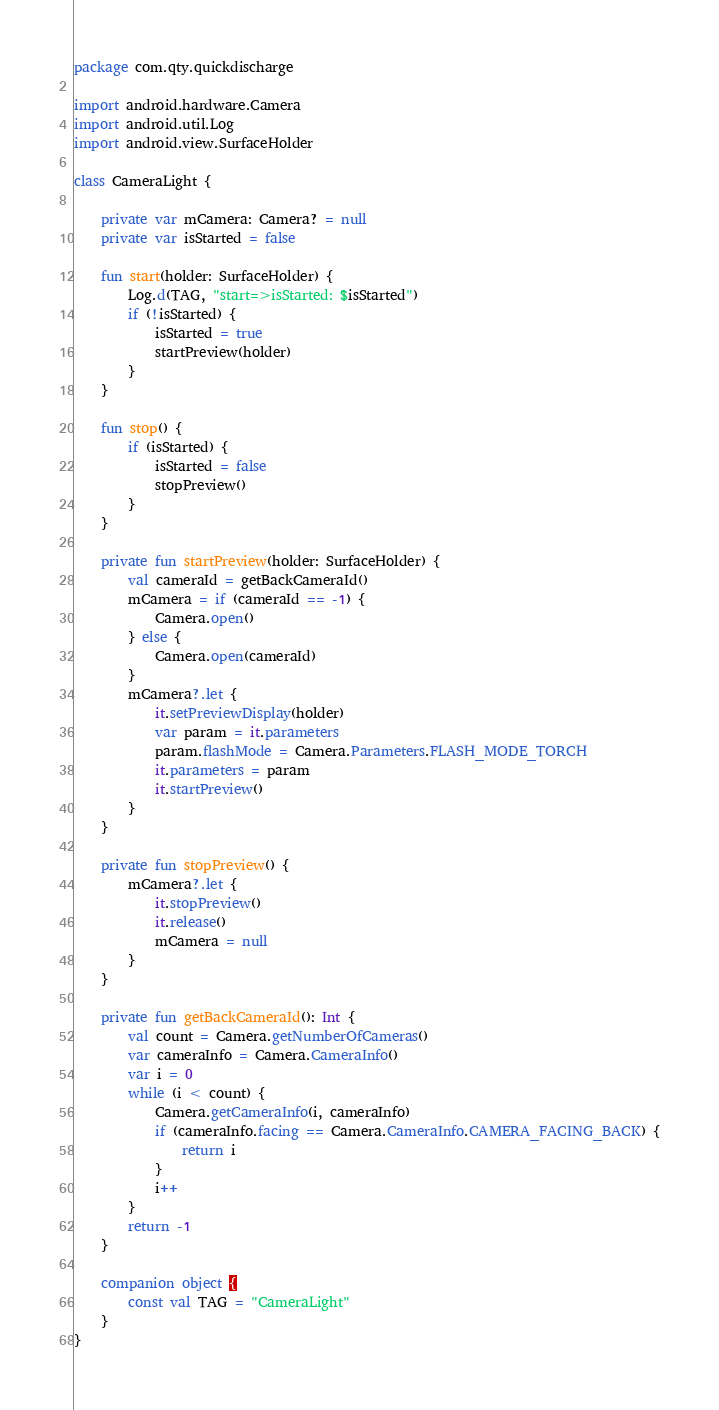Convert code to text. <code><loc_0><loc_0><loc_500><loc_500><_Kotlin_>package com.qty.quickdischarge

import android.hardware.Camera
import android.util.Log
import android.view.SurfaceHolder

class CameraLight {

    private var mCamera: Camera? = null
    private var isStarted = false

    fun start(holder: SurfaceHolder) {
        Log.d(TAG, "start=>isStarted: $isStarted")
        if (!isStarted) {
            isStarted = true
            startPreview(holder)
        }
    }

    fun stop() {
        if (isStarted) {
            isStarted = false
            stopPreview()
        }
    }

    private fun startPreview(holder: SurfaceHolder) {
        val cameraId = getBackCameraId()
        mCamera = if (cameraId == -1) {
            Camera.open()
        } else {
            Camera.open(cameraId)
        }
        mCamera?.let {
            it.setPreviewDisplay(holder)
            var param = it.parameters
            param.flashMode = Camera.Parameters.FLASH_MODE_TORCH
            it.parameters = param
            it.startPreview()
        }
    }

    private fun stopPreview() {
        mCamera?.let {
            it.stopPreview()
            it.release()
            mCamera = null
        }
    }

    private fun getBackCameraId(): Int {
        val count = Camera.getNumberOfCameras()
        var cameraInfo = Camera.CameraInfo()
        var i = 0
        while (i < count) {
            Camera.getCameraInfo(i, cameraInfo)
            if (cameraInfo.facing == Camera.CameraInfo.CAMERA_FACING_BACK) {
                return i
            }
            i++
        }
        return -1
    }

    companion object {
        const val TAG = "CameraLight"
    }
}</code> 